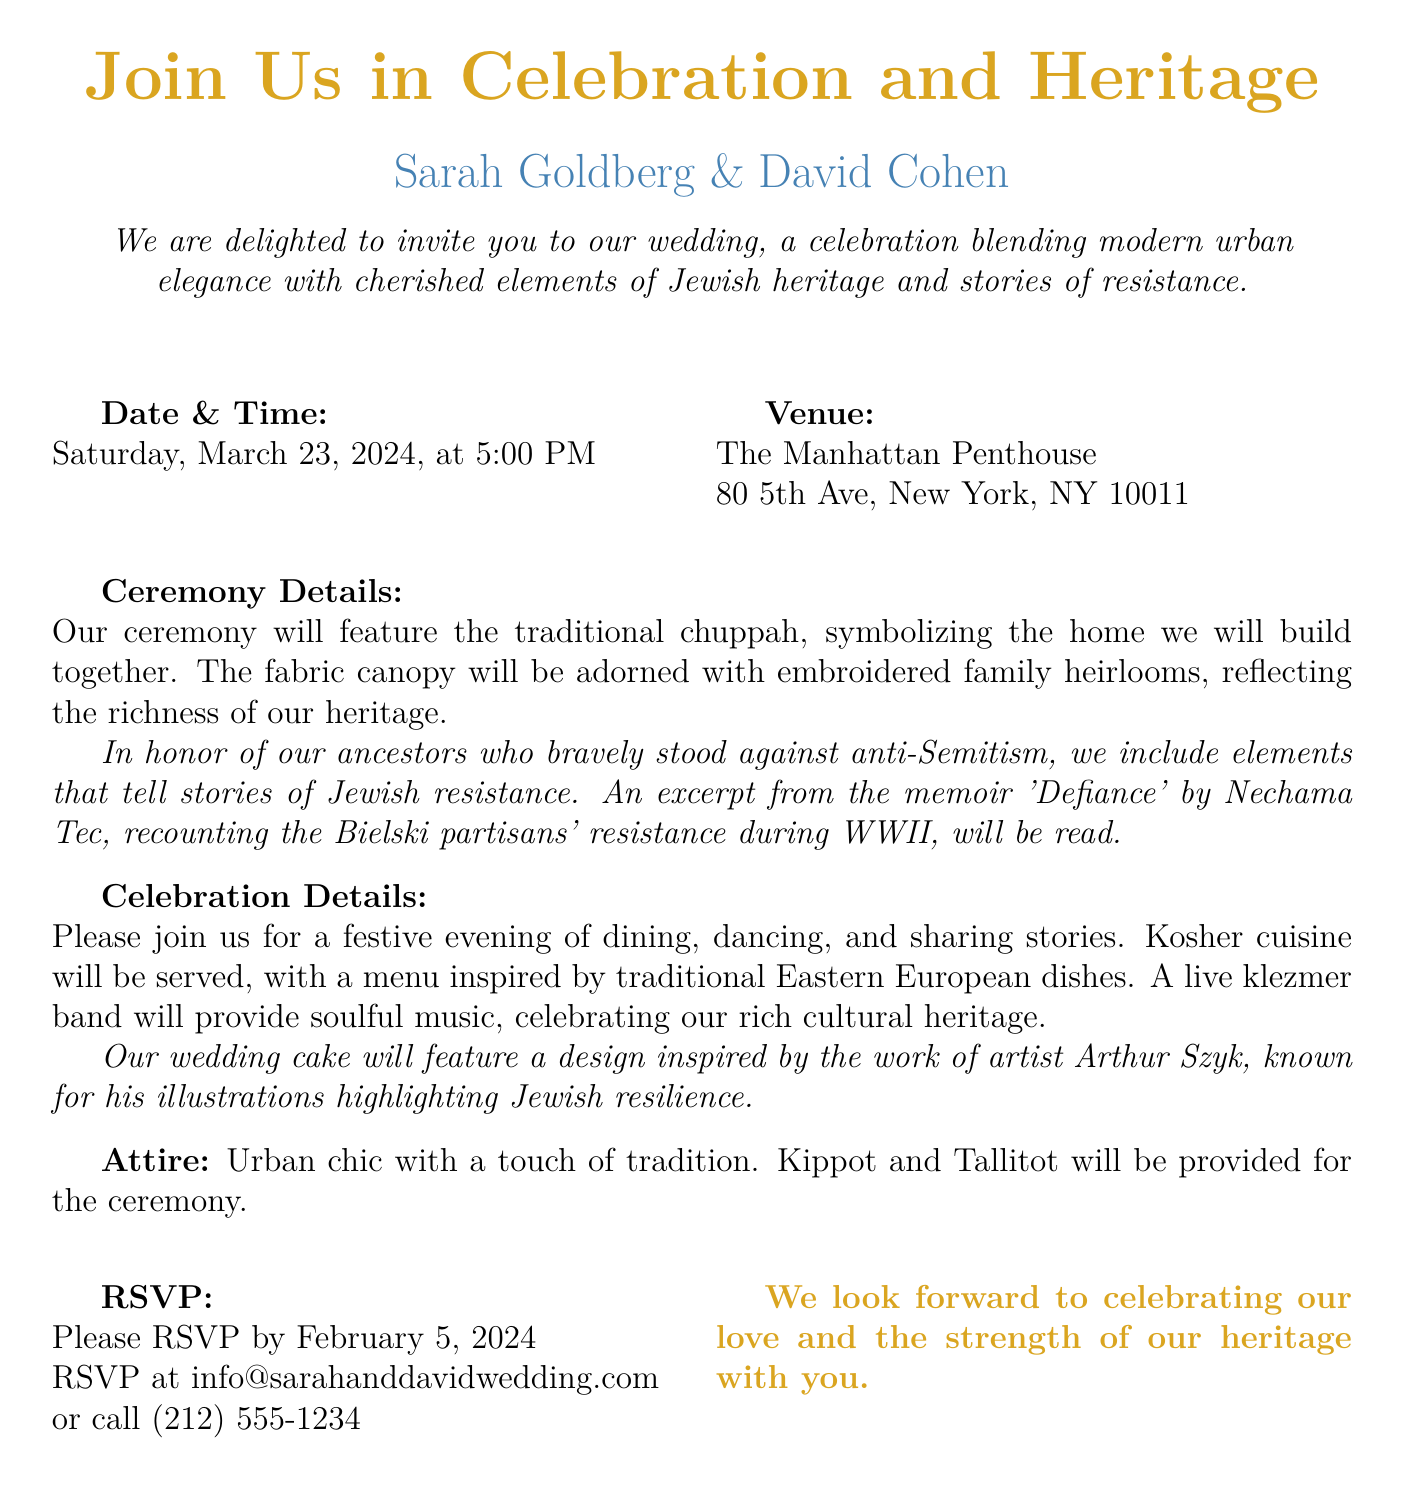What is the date of the wedding? The wedding date is explicitly stated in the invitation as Saturday, March 23, 2024.
Answer: March 23, 2024 What time does the wedding start? The document specifies the start time of the wedding as 5:00 PM.
Answer: 5:00 PM Where is the wedding venue? The invitation provides the venue name and address as The Manhattan Penthouse, 80 5th Ave, New York, NY 10011.
Answer: The Manhattan Penthouse What cultural element will be included in the ceremony? The ceremony will feature a traditional chuppah, which symbolizes the home the couple will build together.
Answer: Chuppah What type of cuisine will be served? The wedding will serve kosher cuisine inspired by traditional Eastern European dishes.
Answer: Kosher cuisine What will be featured on the wedding cake? The cake will have a design inspired by the work of artist Arthur Szyk, known for highlighting Jewish resilience.
Answer: Arthur Szyk What type of music will be played at the celebration? A live klezmer band will provide music, representing the cultural heritage of the couple.
Answer: Klezmer band What is the attire suggestion for guests? The invitation suggests an urban chic outfit with a touch of tradition for the guests.
Answer: Urban chic When is the RSVP deadline? The RSVP deadline is indicated in the document as February 5, 2024.
Answer: February 5, 2024 